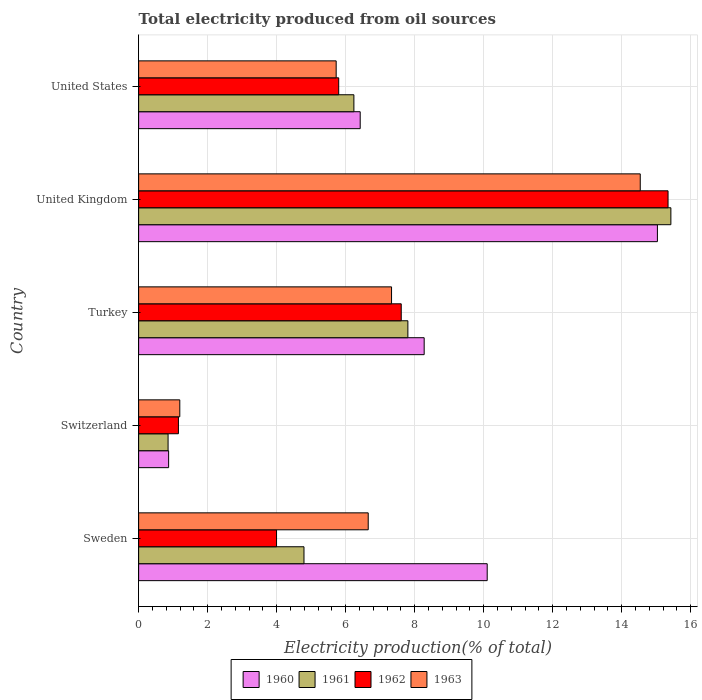How many different coloured bars are there?
Your answer should be compact. 4. Are the number of bars per tick equal to the number of legend labels?
Your answer should be compact. Yes. How many bars are there on the 1st tick from the top?
Provide a short and direct response. 4. What is the label of the 5th group of bars from the top?
Offer a very short reply. Sweden. In how many cases, is the number of bars for a given country not equal to the number of legend labels?
Provide a succinct answer. 0. What is the total electricity produced in 1963 in Sweden?
Offer a very short reply. 6.66. Across all countries, what is the maximum total electricity produced in 1960?
Offer a terse response. 15.04. Across all countries, what is the minimum total electricity produced in 1962?
Make the answer very short. 1.15. In which country was the total electricity produced in 1961 maximum?
Provide a succinct answer. United Kingdom. In which country was the total electricity produced in 1963 minimum?
Offer a very short reply. Switzerland. What is the total total electricity produced in 1961 in the graph?
Your response must be concise. 35.12. What is the difference between the total electricity produced in 1960 in Turkey and that in United States?
Give a very brief answer. 1.85. What is the difference between the total electricity produced in 1962 in Switzerland and the total electricity produced in 1963 in United Kingdom?
Make the answer very short. -13.39. What is the average total electricity produced in 1962 per country?
Offer a very short reply. 6.78. What is the difference between the total electricity produced in 1961 and total electricity produced in 1960 in Switzerland?
Keep it short and to the point. -0.02. What is the ratio of the total electricity produced in 1960 in Switzerland to that in United States?
Make the answer very short. 0.14. Is the difference between the total electricity produced in 1961 in Switzerland and United States greater than the difference between the total electricity produced in 1960 in Switzerland and United States?
Make the answer very short. Yes. What is the difference between the highest and the second highest total electricity produced in 1962?
Offer a terse response. 7.73. What is the difference between the highest and the lowest total electricity produced in 1962?
Keep it short and to the point. 14.19. In how many countries, is the total electricity produced in 1963 greater than the average total electricity produced in 1963 taken over all countries?
Make the answer very short. 2. What does the 4th bar from the top in Turkey represents?
Provide a succinct answer. 1960. Are all the bars in the graph horizontal?
Provide a short and direct response. Yes. How many countries are there in the graph?
Provide a succinct answer. 5. What is the difference between two consecutive major ticks on the X-axis?
Give a very brief answer. 2. Does the graph contain grids?
Offer a very short reply. Yes. Where does the legend appear in the graph?
Make the answer very short. Bottom center. How are the legend labels stacked?
Offer a very short reply. Horizontal. What is the title of the graph?
Provide a succinct answer. Total electricity produced from oil sources. What is the Electricity production(% of total) of 1960 in Sweden?
Keep it short and to the point. 10.1. What is the Electricity production(% of total) in 1961 in Sweden?
Provide a succinct answer. 4.79. What is the Electricity production(% of total) of 1962 in Sweden?
Make the answer very short. 4. What is the Electricity production(% of total) in 1963 in Sweden?
Offer a terse response. 6.66. What is the Electricity production(% of total) of 1960 in Switzerland?
Give a very brief answer. 0.87. What is the Electricity production(% of total) of 1961 in Switzerland?
Offer a very short reply. 0.85. What is the Electricity production(% of total) of 1962 in Switzerland?
Provide a succinct answer. 1.15. What is the Electricity production(% of total) in 1963 in Switzerland?
Offer a terse response. 1.19. What is the Electricity production(% of total) of 1960 in Turkey?
Your answer should be very brief. 8.28. What is the Electricity production(% of total) in 1961 in Turkey?
Provide a succinct answer. 7.8. What is the Electricity production(% of total) in 1962 in Turkey?
Ensure brevity in your answer.  7.61. What is the Electricity production(% of total) in 1963 in Turkey?
Your answer should be compact. 7.33. What is the Electricity production(% of total) of 1960 in United Kingdom?
Make the answer very short. 15.04. What is the Electricity production(% of total) of 1961 in United Kingdom?
Your answer should be very brief. 15.43. What is the Electricity production(% of total) of 1962 in United Kingdom?
Make the answer very short. 15.35. What is the Electricity production(% of total) in 1963 in United Kingdom?
Your answer should be very brief. 14.54. What is the Electricity production(% of total) of 1960 in United States?
Your answer should be very brief. 6.42. What is the Electricity production(% of total) in 1961 in United States?
Your answer should be compact. 6.24. What is the Electricity production(% of total) of 1962 in United States?
Give a very brief answer. 5.8. What is the Electricity production(% of total) of 1963 in United States?
Your answer should be very brief. 5.73. Across all countries, what is the maximum Electricity production(% of total) of 1960?
Offer a terse response. 15.04. Across all countries, what is the maximum Electricity production(% of total) of 1961?
Offer a very short reply. 15.43. Across all countries, what is the maximum Electricity production(% of total) in 1962?
Your response must be concise. 15.35. Across all countries, what is the maximum Electricity production(% of total) in 1963?
Ensure brevity in your answer.  14.54. Across all countries, what is the minimum Electricity production(% of total) of 1960?
Give a very brief answer. 0.87. Across all countries, what is the minimum Electricity production(% of total) in 1961?
Keep it short and to the point. 0.85. Across all countries, what is the minimum Electricity production(% of total) in 1962?
Your answer should be very brief. 1.15. Across all countries, what is the minimum Electricity production(% of total) of 1963?
Offer a terse response. 1.19. What is the total Electricity production(% of total) of 1960 in the graph?
Your response must be concise. 40.71. What is the total Electricity production(% of total) in 1961 in the graph?
Offer a very short reply. 35.12. What is the total Electricity production(% of total) in 1962 in the graph?
Offer a very short reply. 33.91. What is the total Electricity production(% of total) of 1963 in the graph?
Ensure brevity in your answer.  35.45. What is the difference between the Electricity production(% of total) of 1960 in Sweden and that in Switzerland?
Provide a short and direct response. 9.23. What is the difference between the Electricity production(% of total) of 1961 in Sweden and that in Switzerland?
Your answer should be very brief. 3.94. What is the difference between the Electricity production(% of total) in 1962 in Sweden and that in Switzerland?
Make the answer very short. 2.84. What is the difference between the Electricity production(% of total) in 1963 in Sweden and that in Switzerland?
Provide a succinct answer. 5.46. What is the difference between the Electricity production(% of total) of 1960 in Sweden and that in Turkey?
Keep it short and to the point. 1.83. What is the difference between the Electricity production(% of total) in 1961 in Sweden and that in Turkey?
Your answer should be very brief. -3.01. What is the difference between the Electricity production(% of total) of 1962 in Sweden and that in Turkey?
Offer a very short reply. -3.61. What is the difference between the Electricity production(% of total) of 1963 in Sweden and that in Turkey?
Your answer should be very brief. -0.68. What is the difference between the Electricity production(% of total) of 1960 in Sweden and that in United Kingdom?
Provide a short and direct response. -4.93. What is the difference between the Electricity production(% of total) of 1961 in Sweden and that in United Kingdom?
Offer a very short reply. -10.64. What is the difference between the Electricity production(% of total) in 1962 in Sweden and that in United Kingdom?
Your response must be concise. -11.35. What is the difference between the Electricity production(% of total) of 1963 in Sweden and that in United Kingdom?
Provide a short and direct response. -7.89. What is the difference between the Electricity production(% of total) in 1960 in Sweden and that in United States?
Make the answer very short. 3.68. What is the difference between the Electricity production(% of total) of 1961 in Sweden and that in United States?
Provide a succinct answer. -1.45. What is the difference between the Electricity production(% of total) in 1962 in Sweden and that in United States?
Your response must be concise. -1.8. What is the difference between the Electricity production(% of total) of 1963 in Sweden and that in United States?
Ensure brevity in your answer.  0.93. What is the difference between the Electricity production(% of total) of 1960 in Switzerland and that in Turkey?
Make the answer very short. -7.41. What is the difference between the Electricity production(% of total) in 1961 in Switzerland and that in Turkey?
Offer a terse response. -6.95. What is the difference between the Electricity production(% of total) of 1962 in Switzerland and that in Turkey?
Provide a succinct answer. -6.46. What is the difference between the Electricity production(% of total) of 1963 in Switzerland and that in Turkey?
Make the answer very short. -6.14. What is the difference between the Electricity production(% of total) in 1960 in Switzerland and that in United Kingdom?
Offer a very short reply. -14.17. What is the difference between the Electricity production(% of total) of 1961 in Switzerland and that in United Kingdom?
Make the answer very short. -14.57. What is the difference between the Electricity production(% of total) in 1962 in Switzerland and that in United Kingdom?
Offer a terse response. -14.19. What is the difference between the Electricity production(% of total) in 1963 in Switzerland and that in United Kingdom?
Keep it short and to the point. -13.35. What is the difference between the Electricity production(% of total) of 1960 in Switzerland and that in United States?
Your response must be concise. -5.55. What is the difference between the Electricity production(% of total) in 1961 in Switzerland and that in United States?
Provide a succinct answer. -5.39. What is the difference between the Electricity production(% of total) of 1962 in Switzerland and that in United States?
Your response must be concise. -4.65. What is the difference between the Electricity production(% of total) of 1963 in Switzerland and that in United States?
Keep it short and to the point. -4.53. What is the difference between the Electricity production(% of total) in 1960 in Turkey and that in United Kingdom?
Provide a short and direct response. -6.76. What is the difference between the Electricity production(% of total) of 1961 in Turkey and that in United Kingdom?
Your answer should be compact. -7.62. What is the difference between the Electricity production(% of total) in 1962 in Turkey and that in United Kingdom?
Provide a short and direct response. -7.73. What is the difference between the Electricity production(% of total) of 1963 in Turkey and that in United Kingdom?
Your answer should be very brief. -7.21. What is the difference between the Electricity production(% of total) of 1960 in Turkey and that in United States?
Keep it short and to the point. 1.85. What is the difference between the Electricity production(% of total) of 1961 in Turkey and that in United States?
Your response must be concise. 1.56. What is the difference between the Electricity production(% of total) in 1962 in Turkey and that in United States?
Keep it short and to the point. 1.81. What is the difference between the Electricity production(% of total) in 1963 in Turkey and that in United States?
Provide a short and direct response. 1.6. What is the difference between the Electricity production(% of total) of 1960 in United Kingdom and that in United States?
Your response must be concise. 8.62. What is the difference between the Electricity production(% of total) of 1961 in United Kingdom and that in United States?
Your answer should be very brief. 9.19. What is the difference between the Electricity production(% of total) of 1962 in United Kingdom and that in United States?
Your response must be concise. 9.55. What is the difference between the Electricity production(% of total) in 1963 in United Kingdom and that in United States?
Your response must be concise. 8.81. What is the difference between the Electricity production(% of total) in 1960 in Sweden and the Electricity production(% of total) in 1961 in Switzerland?
Provide a succinct answer. 9.25. What is the difference between the Electricity production(% of total) in 1960 in Sweden and the Electricity production(% of total) in 1962 in Switzerland?
Your response must be concise. 8.95. What is the difference between the Electricity production(% of total) of 1960 in Sweden and the Electricity production(% of total) of 1963 in Switzerland?
Provide a short and direct response. 8.91. What is the difference between the Electricity production(% of total) of 1961 in Sweden and the Electricity production(% of total) of 1962 in Switzerland?
Ensure brevity in your answer.  3.64. What is the difference between the Electricity production(% of total) of 1961 in Sweden and the Electricity production(% of total) of 1963 in Switzerland?
Keep it short and to the point. 3.6. What is the difference between the Electricity production(% of total) of 1962 in Sweden and the Electricity production(% of total) of 1963 in Switzerland?
Ensure brevity in your answer.  2.8. What is the difference between the Electricity production(% of total) of 1960 in Sweden and the Electricity production(% of total) of 1961 in Turkey?
Provide a short and direct response. 2.3. What is the difference between the Electricity production(% of total) of 1960 in Sweden and the Electricity production(% of total) of 1962 in Turkey?
Provide a short and direct response. 2.49. What is the difference between the Electricity production(% of total) in 1960 in Sweden and the Electricity production(% of total) in 1963 in Turkey?
Keep it short and to the point. 2.77. What is the difference between the Electricity production(% of total) in 1961 in Sweden and the Electricity production(% of total) in 1962 in Turkey?
Keep it short and to the point. -2.82. What is the difference between the Electricity production(% of total) in 1961 in Sweden and the Electricity production(% of total) in 1963 in Turkey?
Offer a very short reply. -2.54. What is the difference between the Electricity production(% of total) of 1962 in Sweden and the Electricity production(% of total) of 1963 in Turkey?
Your response must be concise. -3.33. What is the difference between the Electricity production(% of total) of 1960 in Sweden and the Electricity production(% of total) of 1961 in United Kingdom?
Your response must be concise. -5.32. What is the difference between the Electricity production(% of total) in 1960 in Sweden and the Electricity production(% of total) in 1962 in United Kingdom?
Your answer should be compact. -5.24. What is the difference between the Electricity production(% of total) in 1960 in Sweden and the Electricity production(% of total) in 1963 in United Kingdom?
Offer a terse response. -4.44. What is the difference between the Electricity production(% of total) in 1961 in Sweden and the Electricity production(% of total) in 1962 in United Kingdom?
Your answer should be compact. -10.55. What is the difference between the Electricity production(% of total) of 1961 in Sweden and the Electricity production(% of total) of 1963 in United Kingdom?
Give a very brief answer. -9.75. What is the difference between the Electricity production(% of total) of 1962 in Sweden and the Electricity production(% of total) of 1963 in United Kingdom?
Provide a succinct answer. -10.54. What is the difference between the Electricity production(% of total) of 1960 in Sweden and the Electricity production(% of total) of 1961 in United States?
Keep it short and to the point. 3.86. What is the difference between the Electricity production(% of total) in 1960 in Sweden and the Electricity production(% of total) in 1962 in United States?
Your answer should be compact. 4.3. What is the difference between the Electricity production(% of total) in 1960 in Sweden and the Electricity production(% of total) in 1963 in United States?
Your answer should be compact. 4.38. What is the difference between the Electricity production(% of total) of 1961 in Sweden and the Electricity production(% of total) of 1962 in United States?
Provide a short and direct response. -1.01. What is the difference between the Electricity production(% of total) of 1961 in Sweden and the Electricity production(% of total) of 1963 in United States?
Your answer should be compact. -0.93. What is the difference between the Electricity production(% of total) of 1962 in Sweden and the Electricity production(% of total) of 1963 in United States?
Offer a very short reply. -1.73. What is the difference between the Electricity production(% of total) of 1960 in Switzerland and the Electricity production(% of total) of 1961 in Turkey?
Offer a terse response. -6.94. What is the difference between the Electricity production(% of total) of 1960 in Switzerland and the Electricity production(% of total) of 1962 in Turkey?
Ensure brevity in your answer.  -6.74. What is the difference between the Electricity production(% of total) of 1960 in Switzerland and the Electricity production(% of total) of 1963 in Turkey?
Make the answer very short. -6.46. What is the difference between the Electricity production(% of total) of 1961 in Switzerland and the Electricity production(% of total) of 1962 in Turkey?
Your answer should be very brief. -6.76. What is the difference between the Electricity production(% of total) of 1961 in Switzerland and the Electricity production(% of total) of 1963 in Turkey?
Keep it short and to the point. -6.48. What is the difference between the Electricity production(% of total) of 1962 in Switzerland and the Electricity production(% of total) of 1963 in Turkey?
Your answer should be compact. -6.18. What is the difference between the Electricity production(% of total) in 1960 in Switzerland and the Electricity production(% of total) in 1961 in United Kingdom?
Make the answer very short. -14.56. What is the difference between the Electricity production(% of total) in 1960 in Switzerland and the Electricity production(% of total) in 1962 in United Kingdom?
Give a very brief answer. -14.48. What is the difference between the Electricity production(% of total) of 1960 in Switzerland and the Electricity production(% of total) of 1963 in United Kingdom?
Your answer should be very brief. -13.67. What is the difference between the Electricity production(% of total) of 1961 in Switzerland and the Electricity production(% of total) of 1962 in United Kingdom?
Give a very brief answer. -14.49. What is the difference between the Electricity production(% of total) of 1961 in Switzerland and the Electricity production(% of total) of 1963 in United Kingdom?
Ensure brevity in your answer.  -13.69. What is the difference between the Electricity production(% of total) in 1962 in Switzerland and the Electricity production(% of total) in 1963 in United Kingdom?
Your response must be concise. -13.39. What is the difference between the Electricity production(% of total) of 1960 in Switzerland and the Electricity production(% of total) of 1961 in United States?
Provide a short and direct response. -5.37. What is the difference between the Electricity production(% of total) of 1960 in Switzerland and the Electricity production(% of total) of 1962 in United States?
Your answer should be compact. -4.93. What is the difference between the Electricity production(% of total) of 1960 in Switzerland and the Electricity production(% of total) of 1963 in United States?
Keep it short and to the point. -4.86. What is the difference between the Electricity production(% of total) in 1961 in Switzerland and the Electricity production(% of total) in 1962 in United States?
Provide a succinct answer. -4.95. What is the difference between the Electricity production(% of total) of 1961 in Switzerland and the Electricity production(% of total) of 1963 in United States?
Give a very brief answer. -4.87. What is the difference between the Electricity production(% of total) in 1962 in Switzerland and the Electricity production(% of total) in 1963 in United States?
Your answer should be very brief. -4.57. What is the difference between the Electricity production(% of total) in 1960 in Turkey and the Electricity production(% of total) in 1961 in United Kingdom?
Ensure brevity in your answer.  -7.15. What is the difference between the Electricity production(% of total) in 1960 in Turkey and the Electricity production(% of total) in 1962 in United Kingdom?
Ensure brevity in your answer.  -7.07. What is the difference between the Electricity production(% of total) of 1960 in Turkey and the Electricity production(% of total) of 1963 in United Kingdom?
Your answer should be compact. -6.26. What is the difference between the Electricity production(% of total) of 1961 in Turkey and the Electricity production(% of total) of 1962 in United Kingdom?
Your answer should be compact. -7.54. What is the difference between the Electricity production(% of total) in 1961 in Turkey and the Electricity production(% of total) in 1963 in United Kingdom?
Provide a succinct answer. -6.74. What is the difference between the Electricity production(% of total) of 1962 in Turkey and the Electricity production(% of total) of 1963 in United Kingdom?
Provide a succinct answer. -6.93. What is the difference between the Electricity production(% of total) in 1960 in Turkey and the Electricity production(% of total) in 1961 in United States?
Provide a short and direct response. 2.04. What is the difference between the Electricity production(% of total) of 1960 in Turkey and the Electricity production(% of total) of 1962 in United States?
Offer a terse response. 2.48. What is the difference between the Electricity production(% of total) of 1960 in Turkey and the Electricity production(% of total) of 1963 in United States?
Your response must be concise. 2.55. What is the difference between the Electricity production(% of total) in 1961 in Turkey and the Electricity production(% of total) in 1962 in United States?
Offer a very short reply. 2.01. What is the difference between the Electricity production(% of total) of 1961 in Turkey and the Electricity production(% of total) of 1963 in United States?
Provide a short and direct response. 2.08. What is the difference between the Electricity production(% of total) in 1962 in Turkey and the Electricity production(% of total) in 1963 in United States?
Provide a short and direct response. 1.89. What is the difference between the Electricity production(% of total) in 1960 in United Kingdom and the Electricity production(% of total) in 1961 in United States?
Your answer should be compact. 8.8. What is the difference between the Electricity production(% of total) of 1960 in United Kingdom and the Electricity production(% of total) of 1962 in United States?
Offer a very short reply. 9.24. What is the difference between the Electricity production(% of total) of 1960 in United Kingdom and the Electricity production(% of total) of 1963 in United States?
Offer a very short reply. 9.31. What is the difference between the Electricity production(% of total) of 1961 in United Kingdom and the Electricity production(% of total) of 1962 in United States?
Ensure brevity in your answer.  9.63. What is the difference between the Electricity production(% of total) in 1961 in United Kingdom and the Electricity production(% of total) in 1963 in United States?
Give a very brief answer. 9.7. What is the difference between the Electricity production(% of total) in 1962 in United Kingdom and the Electricity production(% of total) in 1963 in United States?
Give a very brief answer. 9.62. What is the average Electricity production(% of total) of 1960 per country?
Ensure brevity in your answer.  8.14. What is the average Electricity production(% of total) of 1961 per country?
Provide a short and direct response. 7.02. What is the average Electricity production(% of total) in 1962 per country?
Your response must be concise. 6.78. What is the average Electricity production(% of total) in 1963 per country?
Your answer should be very brief. 7.09. What is the difference between the Electricity production(% of total) of 1960 and Electricity production(% of total) of 1961 in Sweden?
Make the answer very short. 5.31. What is the difference between the Electricity production(% of total) of 1960 and Electricity production(% of total) of 1962 in Sweden?
Your response must be concise. 6.11. What is the difference between the Electricity production(% of total) of 1960 and Electricity production(% of total) of 1963 in Sweden?
Your answer should be very brief. 3.45. What is the difference between the Electricity production(% of total) in 1961 and Electricity production(% of total) in 1962 in Sweden?
Offer a terse response. 0.8. What is the difference between the Electricity production(% of total) in 1961 and Electricity production(% of total) in 1963 in Sweden?
Your response must be concise. -1.86. What is the difference between the Electricity production(% of total) in 1962 and Electricity production(% of total) in 1963 in Sweden?
Offer a terse response. -2.66. What is the difference between the Electricity production(% of total) of 1960 and Electricity production(% of total) of 1961 in Switzerland?
Your response must be concise. 0.02. What is the difference between the Electricity production(% of total) of 1960 and Electricity production(% of total) of 1962 in Switzerland?
Ensure brevity in your answer.  -0.28. What is the difference between the Electricity production(% of total) in 1960 and Electricity production(% of total) in 1963 in Switzerland?
Provide a short and direct response. -0.32. What is the difference between the Electricity production(% of total) of 1961 and Electricity production(% of total) of 1962 in Switzerland?
Your answer should be very brief. -0.3. What is the difference between the Electricity production(% of total) in 1961 and Electricity production(% of total) in 1963 in Switzerland?
Offer a very short reply. -0.34. What is the difference between the Electricity production(% of total) of 1962 and Electricity production(% of total) of 1963 in Switzerland?
Ensure brevity in your answer.  -0.04. What is the difference between the Electricity production(% of total) in 1960 and Electricity production(% of total) in 1961 in Turkey?
Provide a short and direct response. 0.47. What is the difference between the Electricity production(% of total) of 1960 and Electricity production(% of total) of 1962 in Turkey?
Keep it short and to the point. 0.66. What is the difference between the Electricity production(% of total) of 1960 and Electricity production(% of total) of 1963 in Turkey?
Your response must be concise. 0.95. What is the difference between the Electricity production(% of total) in 1961 and Electricity production(% of total) in 1962 in Turkey?
Your answer should be very brief. 0.19. What is the difference between the Electricity production(% of total) in 1961 and Electricity production(% of total) in 1963 in Turkey?
Your response must be concise. 0.47. What is the difference between the Electricity production(% of total) of 1962 and Electricity production(% of total) of 1963 in Turkey?
Offer a terse response. 0.28. What is the difference between the Electricity production(% of total) in 1960 and Electricity production(% of total) in 1961 in United Kingdom?
Provide a short and direct response. -0.39. What is the difference between the Electricity production(% of total) in 1960 and Electricity production(% of total) in 1962 in United Kingdom?
Your answer should be very brief. -0.31. What is the difference between the Electricity production(% of total) of 1960 and Electricity production(% of total) of 1963 in United Kingdom?
Keep it short and to the point. 0.5. What is the difference between the Electricity production(% of total) of 1961 and Electricity production(% of total) of 1962 in United Kingdom?
Your answer should be compact. 0.08. What is the difference between the Electricity production(% of total) of 1961 and Electricity production(% of total) of 1963 in United Kingdom?
Offer a terse response. 0.89. What is the difference between the Electricity production(% of total) in 1962 and Electricity production(% of total) in 1963 in United Kingdom?
Offer a terse response. 0.81. What is the difference between the Electricity production(% of total) of 1960 and Electricity production(% of total) of 1961 in United States?
Offer a very short reply. 0.18. What is the difference between the Electricity production(% of total) of 1960 and Electricity production(% of total) of 1962 in United States?
Offer a very short reply. 0.62. What is the difference between the Electricity production(% of total) in 1960 and Electricity production(% of total) in 1963 in United States?
Provide a succinct answer. 0.7. What is the difference between the Electricity production(% of total) of 1961 and Electricity production(% of total) of 1962 in United States?
Your response must be concise. 0.44. What is the difference between the Electricity production(% of total) in 1961 and Electricity production(% of total) in 1963 in United States?
Your answer should be very brief. 0.51. What is the difference between the Electricity production(% of total) in 1962 and Electricity production(% of total) in 1963 in United States?
Give a very brief answer. 0.07. What is the ratio of the Electricity production(% of total) of 1960 in Sweden to that in Switzerland?
Your response must be concise. 11.62. What is the ratio of the Electricity production(% of total) of 1961 in Sweden to that in Switzerland?
Your response must be concise. 5.62. What is the ratio of the Electricity production(% of total) in 1962 in Sweden to that in Switzerland?
Your answer should be compact. 3.47. What is the ratio of the Electricity production(% of total) of 1963 in Sweden to that in Switzerland?
Provide a succinct answer. 5.58. What is the ratio of the Electricity production(% of total) of 1960 in Sweden to that in Turkey?
Offer a very short reply. 1.22. What is the ratio of the Electricity production(% of total) in 1961 in Sweden to that in Turkey?
Your response must be concise. 0.61. What is the ratio of the Electricity production(% of total) in 1962 in Sweden to that in Turkey?
Offer a terse response. 0.53. What is the ratio of the Electricity production(% of total) in 1963 in Sweden to that in Turkey?
Ensure brevity in your answer.  0.91. What is the ratio of the Electricity production(% of total) of 1960 in Sweden to that in United Kingdom?
Ensure brevity in your answer.  0.67. What is the ratio of the Electricity production(% of total) of 1961 in Sweden to that in United Kingdom?
Provide a short and direct response. 0.31. What is the ratio of the Electricity production(% of total) of 1962 in Sweden to that in United Kingdom?
Ensure brevity in your answer.  0.26. What is the ratio of the Electricity production(% of total) of 1963 in Sweden to that in United Kingdom?
Your answer should be compact. 0.46. What is the ratio of the Electricity production(% of total) in 1960 in Sweden to that in United States?
Make the answer very short. 1.57. What is the ratio of the Electricity production(% of total) in 1961 in Sweden to that in United States?
Give a very brief answer. 0.77. What is the ratio of the Electricity production(% of total) in 1962 in Sweden to that in United States?
Your response must be concise. 0.69. What is the ratio of the Electricity production(% of total) of 1963 in Sweden to that in United States?
Provide a succinct answer. 1.16. What is the ratio of the Electricity production(% of total) in 1960 in Switzerland to that in Turkey?
Make the answer very short. 0.11. What is the ratio of the Electricity production(% of total) in 1961 in Switzerland to that in Turkey?
Offer a very short reply. 0.11. What is the ratio of the Electricity production(% of total) of 1962 in Switzerland to that in Turkey?
Keep it short and to the point. 0.15. What is the ratio of the Electricity production(% of total) in 1963 in Switzerland to that in Turkey?
Make the answer very short. 0.16. What is the ratio of the Electricity production(% of total) in 1960 in Switzerland to that in United Kingdom?
Make the answer very short. 0.06. What is the ratio of the Electricity production(% of total) in 1961 in Switzerland to that in United Kingdom?
Keep it short and to the point. 0.06. What is the ratio of the Electricity production(% of total) of 1962 in Switzerland to that in United Kingdom?
Your answer should be compact. 0.08. What is the ratio of the Electricity production(% of total) of 1963 in Switzerland to that in United Kingdom?
Your answer should be compact. 0.08. What is the ratio of the Electricity production(% of total) in 1960 in Switzerland to that in United States?
Keep it short and to the point. 0.14. What is the ratio of the Electricity production(% of total) of 1961 in Switzerland to that in United States?
Your response must be concise. 0.14. What is the ratio of the Electricity production(% of total) in 1962 in Switzerland to that in United States?
Your answer should be very brief. 0.2. What is the ratio of the Electricity production(% of total) in 1963 in Switzerland to that in United States?
Provide a succinct answer. 0.21. What is the ratio of the Electricity production(% of total) in 1960 in Turkey to that in United Kingdom?
Make the answer very short. 0.55. What is the ratio of the Electricity production(% of total) of 1961 in Turkey to that in United Kingdom?
Offer a terse response. 0.51. What is the ratio of the Electricity production(% of total) of 1962 in Turkey to that in United Kingdom?
Your answer should be compact. 0.5. What is the ratio of the Electricity production(% of total) in 1963 in Turkey to that in United Kingdom?
Provide a short and direct response. 0.5. What is the ratio of the Electricity production(% of total) in 1960 in Turkey to that in United States?
Give a very brief answer. 1.29. What is the ratio of the Electricity production(% of total) in 1961 in Turkey to that in United States?
Provide a short and direct response. 1.25. What is the ratio of the Electricity production(% of total) in 1962 in Turkey to that in United States?
Your answer should be compact. 1.31. What is the ratio of the Electricity production(% of total) of 1963 in Turkey to that in United States?
Ensure brevity in your answer.  1.28. What is the ratio of the Electricity production(% of total) in 1960 in United Kingdom to that in United States?
Ensure brevity in your answer.  2.34. What is the ratio of the Electricity production(% of total) in 1961 in United Kingdom to that in United States?
Give a very brief answer. 2.47. What is the ratio of the Electricity production(% of total) in 1962 in United Kingdom to that in United States?
Provide a succinct answer. 2.65. What is the ratio of the Electricity production(% of total) in 1963 in United Kingdom to that in United States?
Ensure brevity in your answer.  2.54. What is the difference between the highest and the second highest Electricity production(% of total) in 1960?
Ensure brevity in your answer.  4.93. What is the difference between the highest and the second highest Electricity production(% of total) of 1961?
Offer a terse response. 7.62. What is the difference between the highest and the second highest Electricity production(% of total) of 1962?
Provide a succinct answer. 7.73. What is the difference between the highest and the second highest Electricity production(% of total) in 1963?
Provide a short and direct response. 7.21. What is the difference between the highest and the lowest Electricity production(% of total) in 1960?
Make the answer very short. 14.17. What is the difference between the highest and the lowest Electricity production(% of total) in 1961?
Offer a very short reply. 14.57. What is the difference between the highest and the lowest Electricity production(% of total) of 1962?
Provide a short and direct response. 14.19. What is the difference between the highest and the lowest Electricity production(% of total) of 1963?
Your response must be concise. 13.35. 